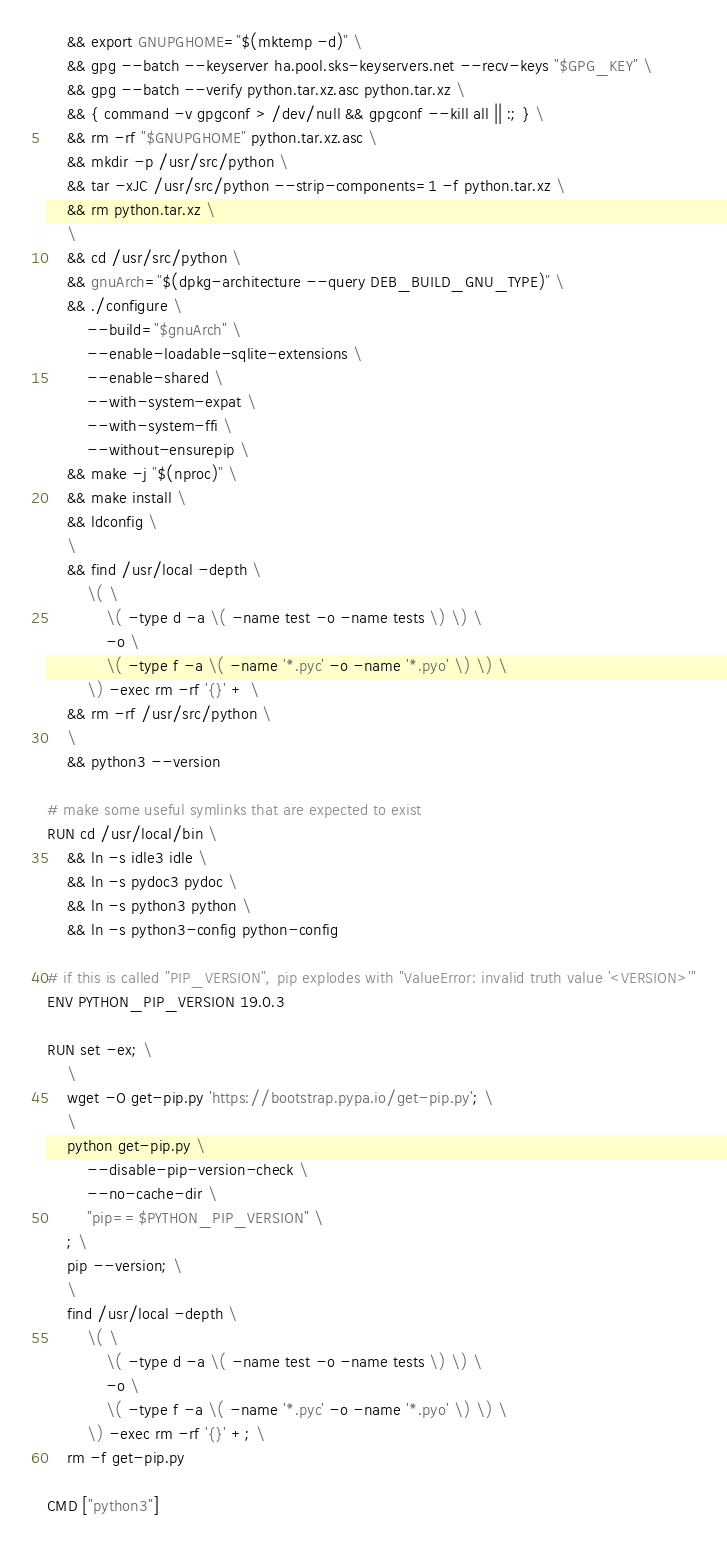Convert code to text. <code><loc_0><loc_0><loc_500><loc_500><_Dockerfile_>	&& export GNUPGHOME="$(mktemp -d)" \
	&& gpg --batch --keyserver ha.pool.sks-keyservers.net --recv-keys "$GPG_KEY" \
	&& gpg --batch --verify python.tar.xz.asc python.tar.xz \
	&& { command -v gpgconf > /dev/null && gpgconf --kill all || :; } \
	&& rm -rf "$GNUPGHOME" python.tar.xz.asc \
	&& mkdir -p /usr/src/python \
	&& tar -xJC /usr/src/python --strip-components=1 -f python.tar.xz \
	&& rm python.tar.xz \
	\
	&& cd /usr/src/python \
	&& gnuArch="$(dpkg-architecture --query DEB_BUILD_GNU_TYPE)" \
	&& ./configure \
		--build="$gnuArch" \
		--enable-loadable-sqlite-extensions \
		--enable-shared \
		--with-system-expat \
		--with-system-ffi \
		--without-ensurepip \
	&& make -j "$(nproc)" \
	&& make install \
	&& ldconfig \
	\
	&& find /usr/local -depth \
		\( \
			\( -type d -a \( -name test -o -name tests \) \) \
			-o \
			\( -type f -a \( -name '*.pyc' -o -name '*.pyo' \) \) \
		\) -exec rm -rf '{}' + \
	&& rm -rf /usr/src/python \
	\
	&& python3 --version

# make some useful symlinks that are expected to exist
RUN cd /usr/local/bin \
	&& ln -s idle3 idle \
	&& ln -s pydoc3 pydoc \
	&& ln -s python3 python \
	&& ln -s python3-config python-config

# if this is called "PIP_VERSION", pip explodes with "ValueError: invalid truth value '<VERSION>'"
ENV PYTHON_PIP_VERSION 19.0.3

RUN set -ex; \
	\
	wget -O get-pip.py 'https://bootstrap.pypa.io/get-pip.py'; \
	\
	python get-pip.py \
		--disable-pip-version-check \
		--no-cache-dir \
		"pip==$PYTHON_PIP_VERSION" \
	; \
	pip --version; \
	\
	find /usr/local -depth \
		\( \
			\( -type d -a \( -name test -o -name tests \) \) \
			-o \
			\( -type f -a \( -name '*.pyc' -o -name '*.pyo' \) \) \
		\) -exec rm -rf '{}' +; \
	rm -f get-pip.py

CMD ["python3"]
</code> 